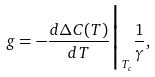Convert formula to latex. <formula><loc_0><loc_0><loc_500><loc_500>g = - \frac { d \Delta C ( T ) } { d T } \Big | _ { T _ { c } } \frac { 1 } { \gamma } ,</formula> 